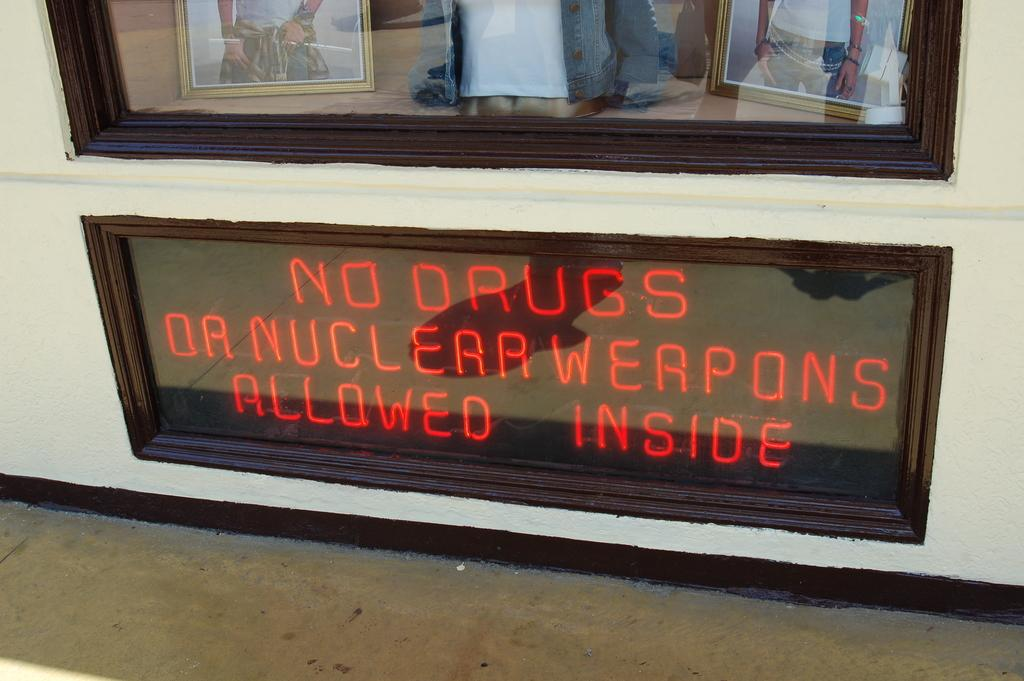What type of display is present in the image? There are LED boards in the image. What material is at the top of the display? There is glass at the top in the image. What is inside the glass? There are two frames inside the glass. Can you describe what is visible in the glass? The reflection of a person is visible in the glass. What type of disgusting pickle is being requested by the person in the image? There is no mention of a pickle or a request in the image. The image only shows LED boards, glass, frames, and a reflection of a person. 